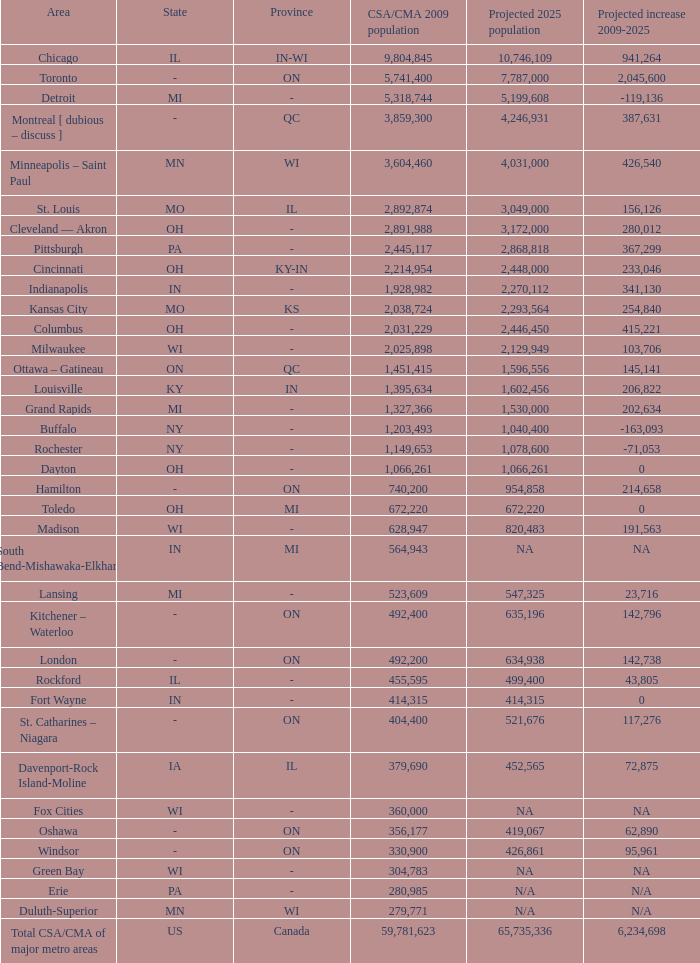What's the projected population of IN-MI? NA. 